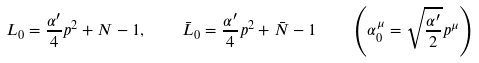<formula> <loc_0><loc_0><loc_500><loc_500>L _ { 0 } = \frac { \alpha ^ { \prime } } { 4 } p ^ { 2 } + N - 1 , \quad \bar { L } _ { 0 } = \frac { \alpha ^ { \prime } } { 4 } p ^ { 2 } + \bar { N } - 1 \quad \left ( \alpha _ { 0 } ^ { \mu } = \sqrt { \frac { \alpha ^ { \prime } } { 2 } } p ^ { \mu } \right )</formula> 